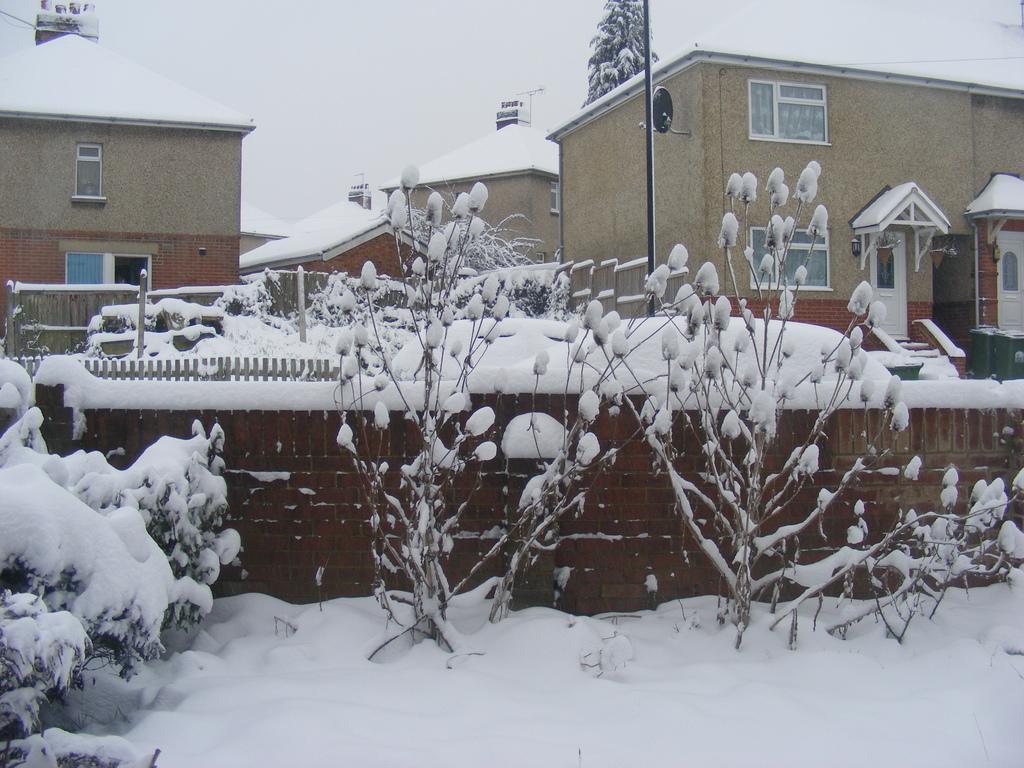Describe this image in one or two sentences. In this image there are buildings, trees, plants, wooden fence are covered with snow. 